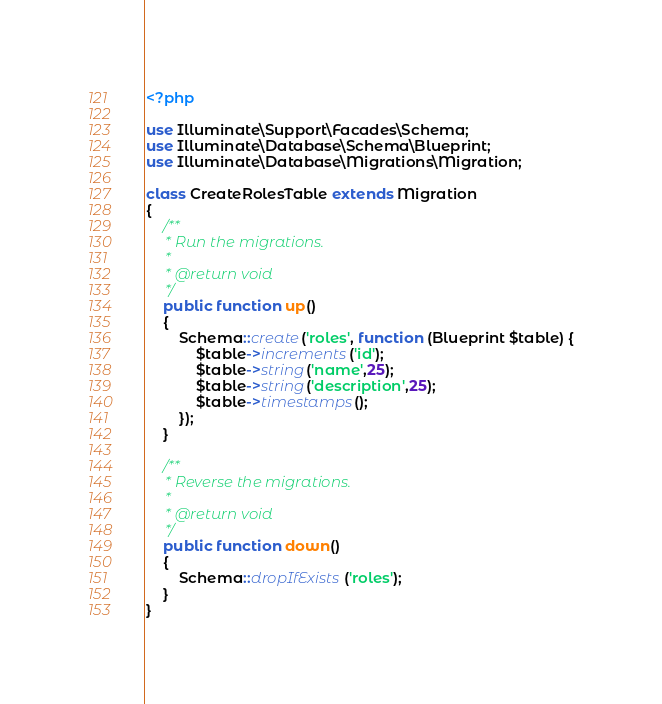<code> <loc_0><loc_0><loc_500><loc_500><_PHP_><?php

use Illuminate\Support\Facades\Schema;
use Illuminate\Database\Schema\Blueprint;
use Illuminate\Database\Migrations\Migration;

class CreateRolesTable extends Migration
{
    /**
     * Run the migrations.
     *
     * @return void
     */
    public function up()
    {
        Schema::create('roles', function (Blueprint $table) {
            $table->increments('id');
            $table->string('name',25);
            $table->string('description',25);
            $table->timestamps();
        });
    }

    /**
     * Reverse the migrations.
     *
     * @return void
     */
    public function down()
    {
        Schema::dropIfExists('roles');
    }
}
</code> 